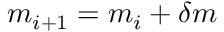Convert formula to latex. <formula><loc_0><loc_0><loc_500><loc_500>m _ { i + 1 } = m _ { i } + \delta m</formula> 